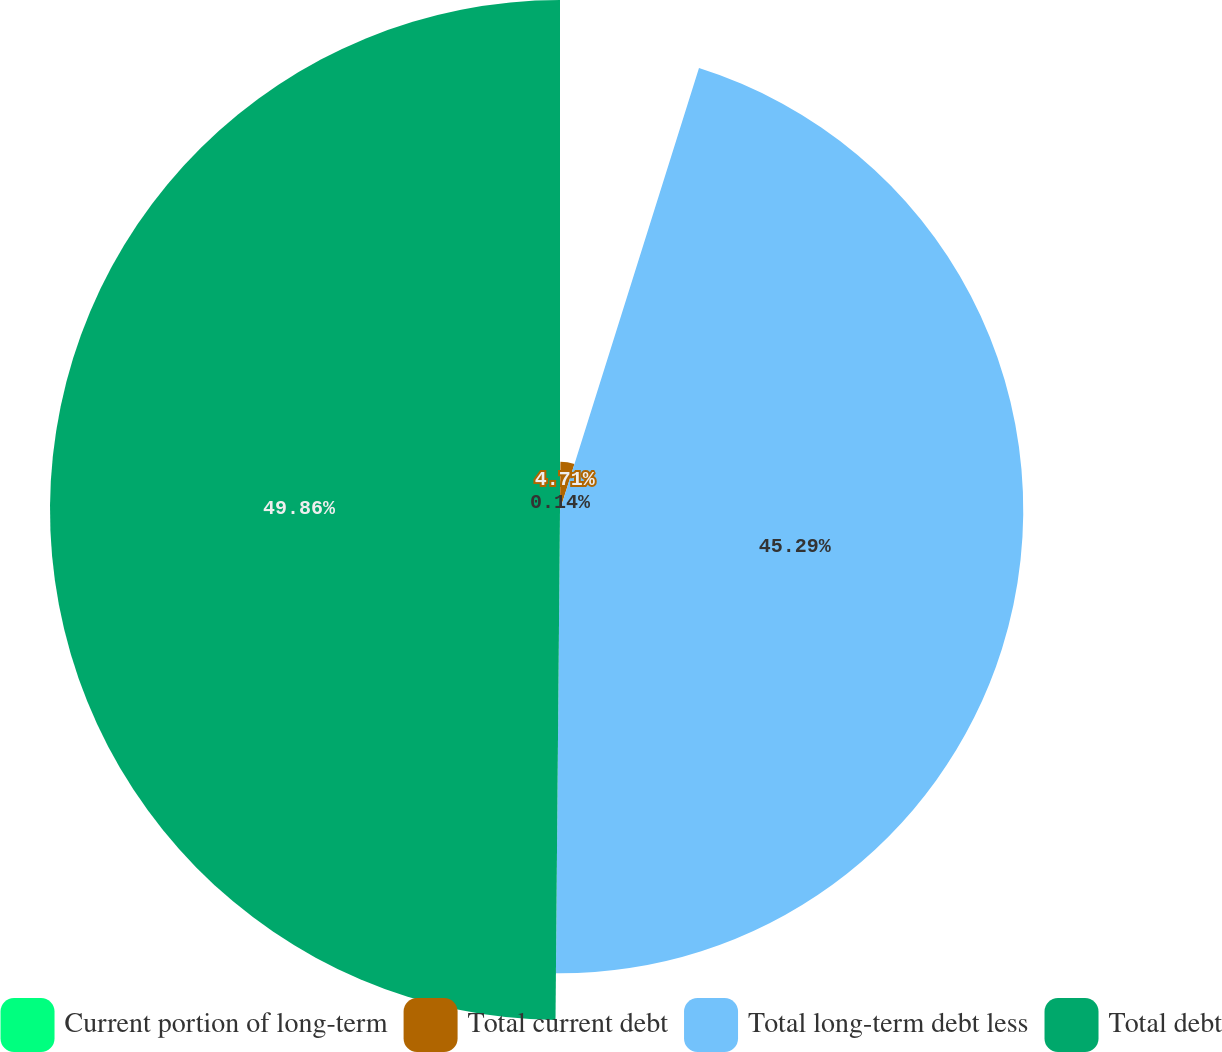Convert chart to OTSL. <chart><loc_0><loc_0><loc_500><loc_500><pie_chart><fcel>Current portion of long-term<fcel>Total current debt<fcel>Total long-term debt less<fcel>Total debt<nl><fcel>0.14%<fcel>4.71%<fcel>45.29%<fcel>49.86%<nl></chart> 